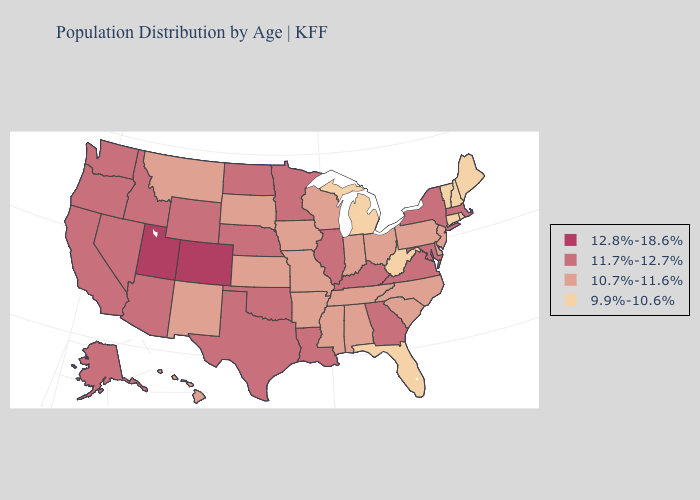Does the map have missing data?
Be succinct. No. What is the lowest value in the USA?
Write a very short answer. 9.9%-10.6%. Which states hav the highest value in the West?
Concise answer only. Colorado, Utah. Does Utah have a lower value than Maine?
Keep it brief. No. Does Florida have the highest value in the South?
Write a very short answer. No. What is the value of New Hampshire?
Be succinct. 9.9%-10.6%. Among the states that border Alabama , does Georgia have the lowest value?
Give a very brief answer. No. Which states have the lowest value in the South?
Short answer required. Florida, West Virginia. What is the lowest value in states that border Delaware?
Give a very brief answer. 10.7%-11.6%. Name the states that have a value in the range 12.8%-18.6%?
Quick response, please. Colorado, Utah. Which states have the highest value in the USA?
Give a very brief answer. Colorado, Utah. What is the value of Kentucky?
Short answer required. 11.7%-12.7%. How many symbols are there in the legend?
Give a very brief answer. 4. Does Illinois have a higher value than Arkansas?
Keep it brief. Yes. What is the value of New Mexico?
Answer briefly. 10.7%-11.6%. 